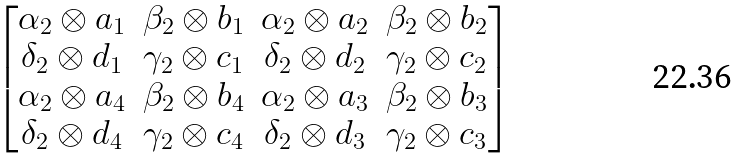Convert formula to latex. <formula><loc_0><loc_0><loc_500><loc_500>\begin{bmatrix} \alpha _ { 2 } \otimes a _ { 1 } & \beta _ { 2 } \otimes b _ { 1 } & \alpha _ { 2 } \otimes a _ { 2 } & \beta _ { 2 } \otimes b _ { 2 } \\ \delta _ { 2 } \otimes d _ { 1 } & \gamma _ { 2 } \otimes c _ { 1 } & \delta _ { 2 } \otimes d _ { 2 } & \gamma _ { 2 } \otimes c _ { 2 } \\ \alpha _ { 2 } \otimes a _ { 4 } & \beta _ { 2 } \otimes b _ { 4 } & \alpha _ { 2 } \otimes a _ { 3 } & \beta _ { 2 } \otimes b _ { 3 } \\ \delta _ { 2 } \otimes d _ { 4 } & \gamma _ { 2 } \otimes c _ { 4 } & \delta _ { 2 } \otimes d _ { 3 } & \gamma _ { 2 } \otimes c _ { 3 } \end{bmatrix}</formula> 